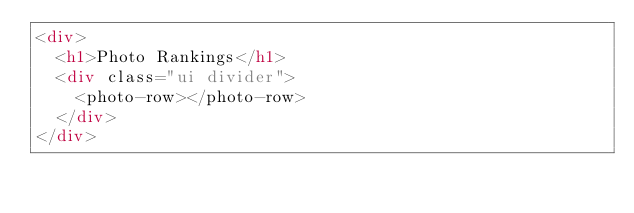<code> <loc_0><loc_0><loc_500><loc_500><_HTML_><div>
  <h1>Photo Rankings</h1>
  <div class="ui divider">
  	<photo-row></photo-row>
  </div>
</div>
</code> 